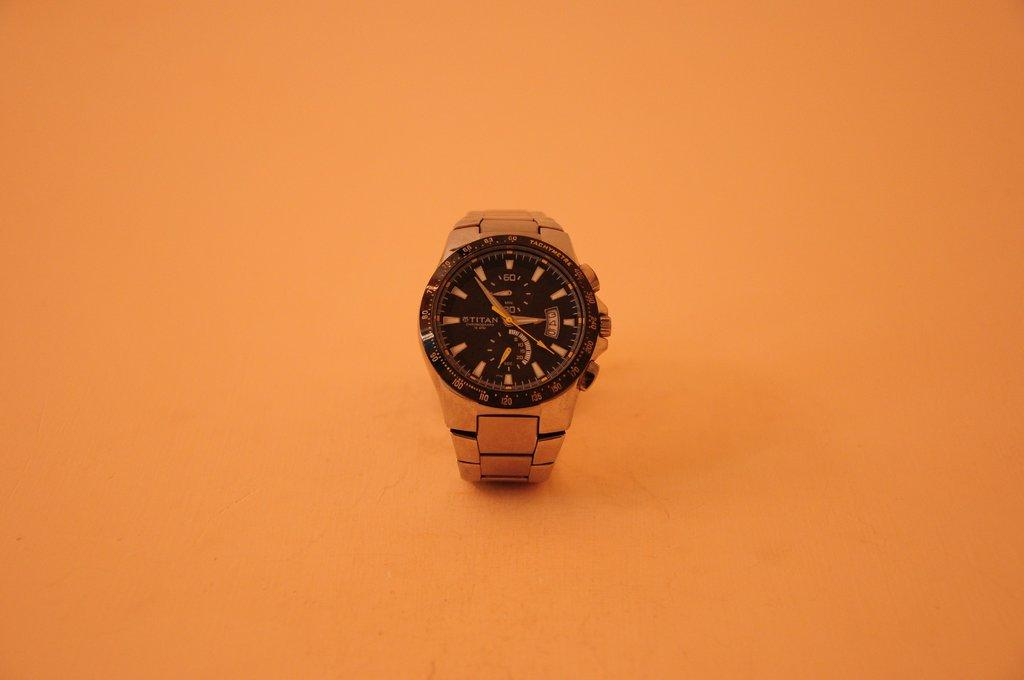<image>
Write a terse but informative summary of the picture. A watch with Titan on the face is in front of an orange background. 